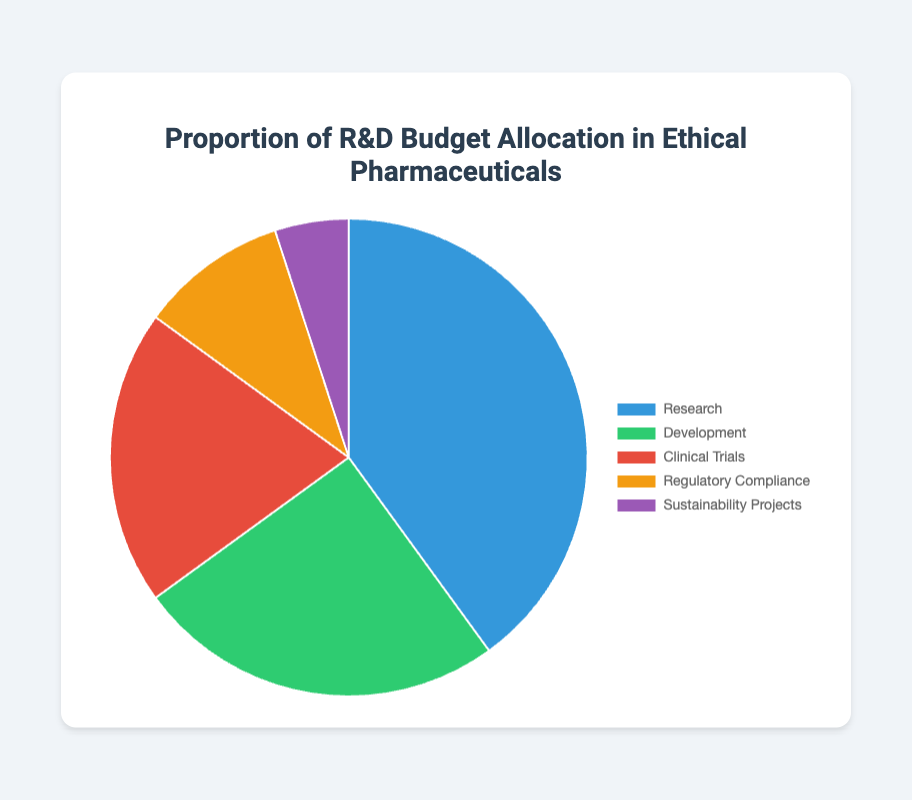Which category receives the highest proportion of the R&D budget? By looking at the pie chart, the largest slice corresponds to Research category.
Answer: Research What is the sum of the allocated percentages for Clinical Trials and Sustainability Projects? Adding the allocated percentages for Clinical Trials (20%) and Sustainability Projects (5%) gives 20 + 5 = 25%.
Answer: 25% Which category has the smallest allocation, and what is its percentage? The smallest slice in the pie chart belongs to the Sustainability Projects category, and its allocation is 5%.
Answer: Sustainability Projects, 5% How does the budget allocated to Development compare with the budget allocated to Regulatory Compliance? The Development category has a larger allocation (25%) compared to Regulatory Compliance (10%).
Answer: Development > Regulatory Compliance What is the total percentage allocated to Development and Research combined? Adding the percentages for Development (25%) and Research (40%) gives 25 + 40 = 65%.
Answer: 65% If the total budget is $10 million, how much is allocated to Clinical Trials? Clinical Trials constitute 20% of the budget. Therefore, 20% of $10 million is 0.20 * $10,000,000 = $2,000,000.
Answer: $2,000,000 Which category is represented by the green color in the pie chart? Observing the pie chart, the green color corresponds to the Development category.
Answer: Development What is the difference in budget allocation between Research and Clinical Trials? Subtracting the Clinical Trials percentage (20%) from the Research percentage (40%) gives 40 - 20 = 20%.
Answer: 20% Out of the total R&D budget, what percentage is not allocated to Research? The percentage not allocated to Research is 100% - 40% (since Research is 40% of the budget), giving 100 - 40 = 60%.
Answer: 60% Between which two categories is the percentage allocation difference the smallest? The categories Development (25%) and Clinical Trials (20%) have the smallest difference in allocation, which is 5% (25 - 20 = 5).
Answer: Development and Clinical Trials 